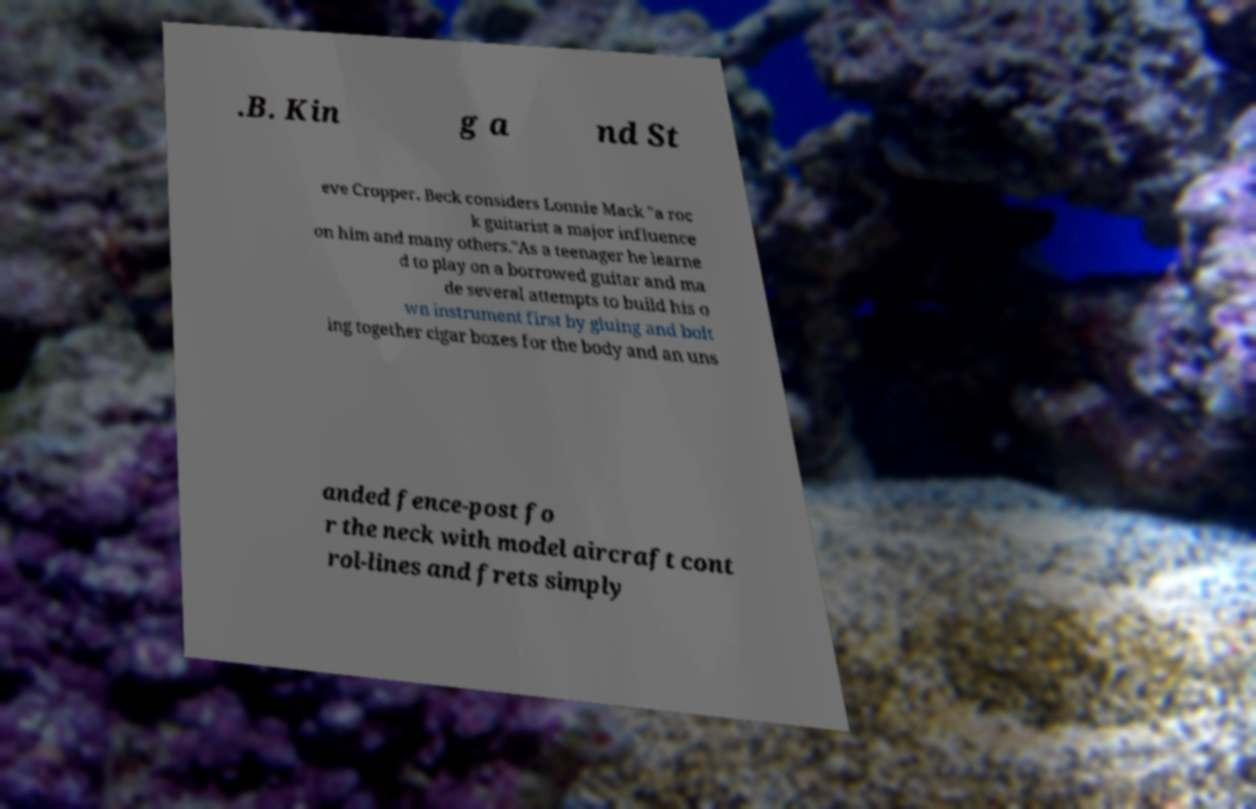Could you extract and type out the text from this image? .B. Kin g a nd St eve Cropper. Beck considers Lonnie Mack "a roc k guitarist a major influence on him and many others."As a teenager he learne d to play on a borrowed guitar and ma de several attempts to build his o wn instrument first by gluing and bolt ing together cigar boxes for the body and an uns anded fence-post fo r the neck with model aircraft cont rol-lines and frets simply 